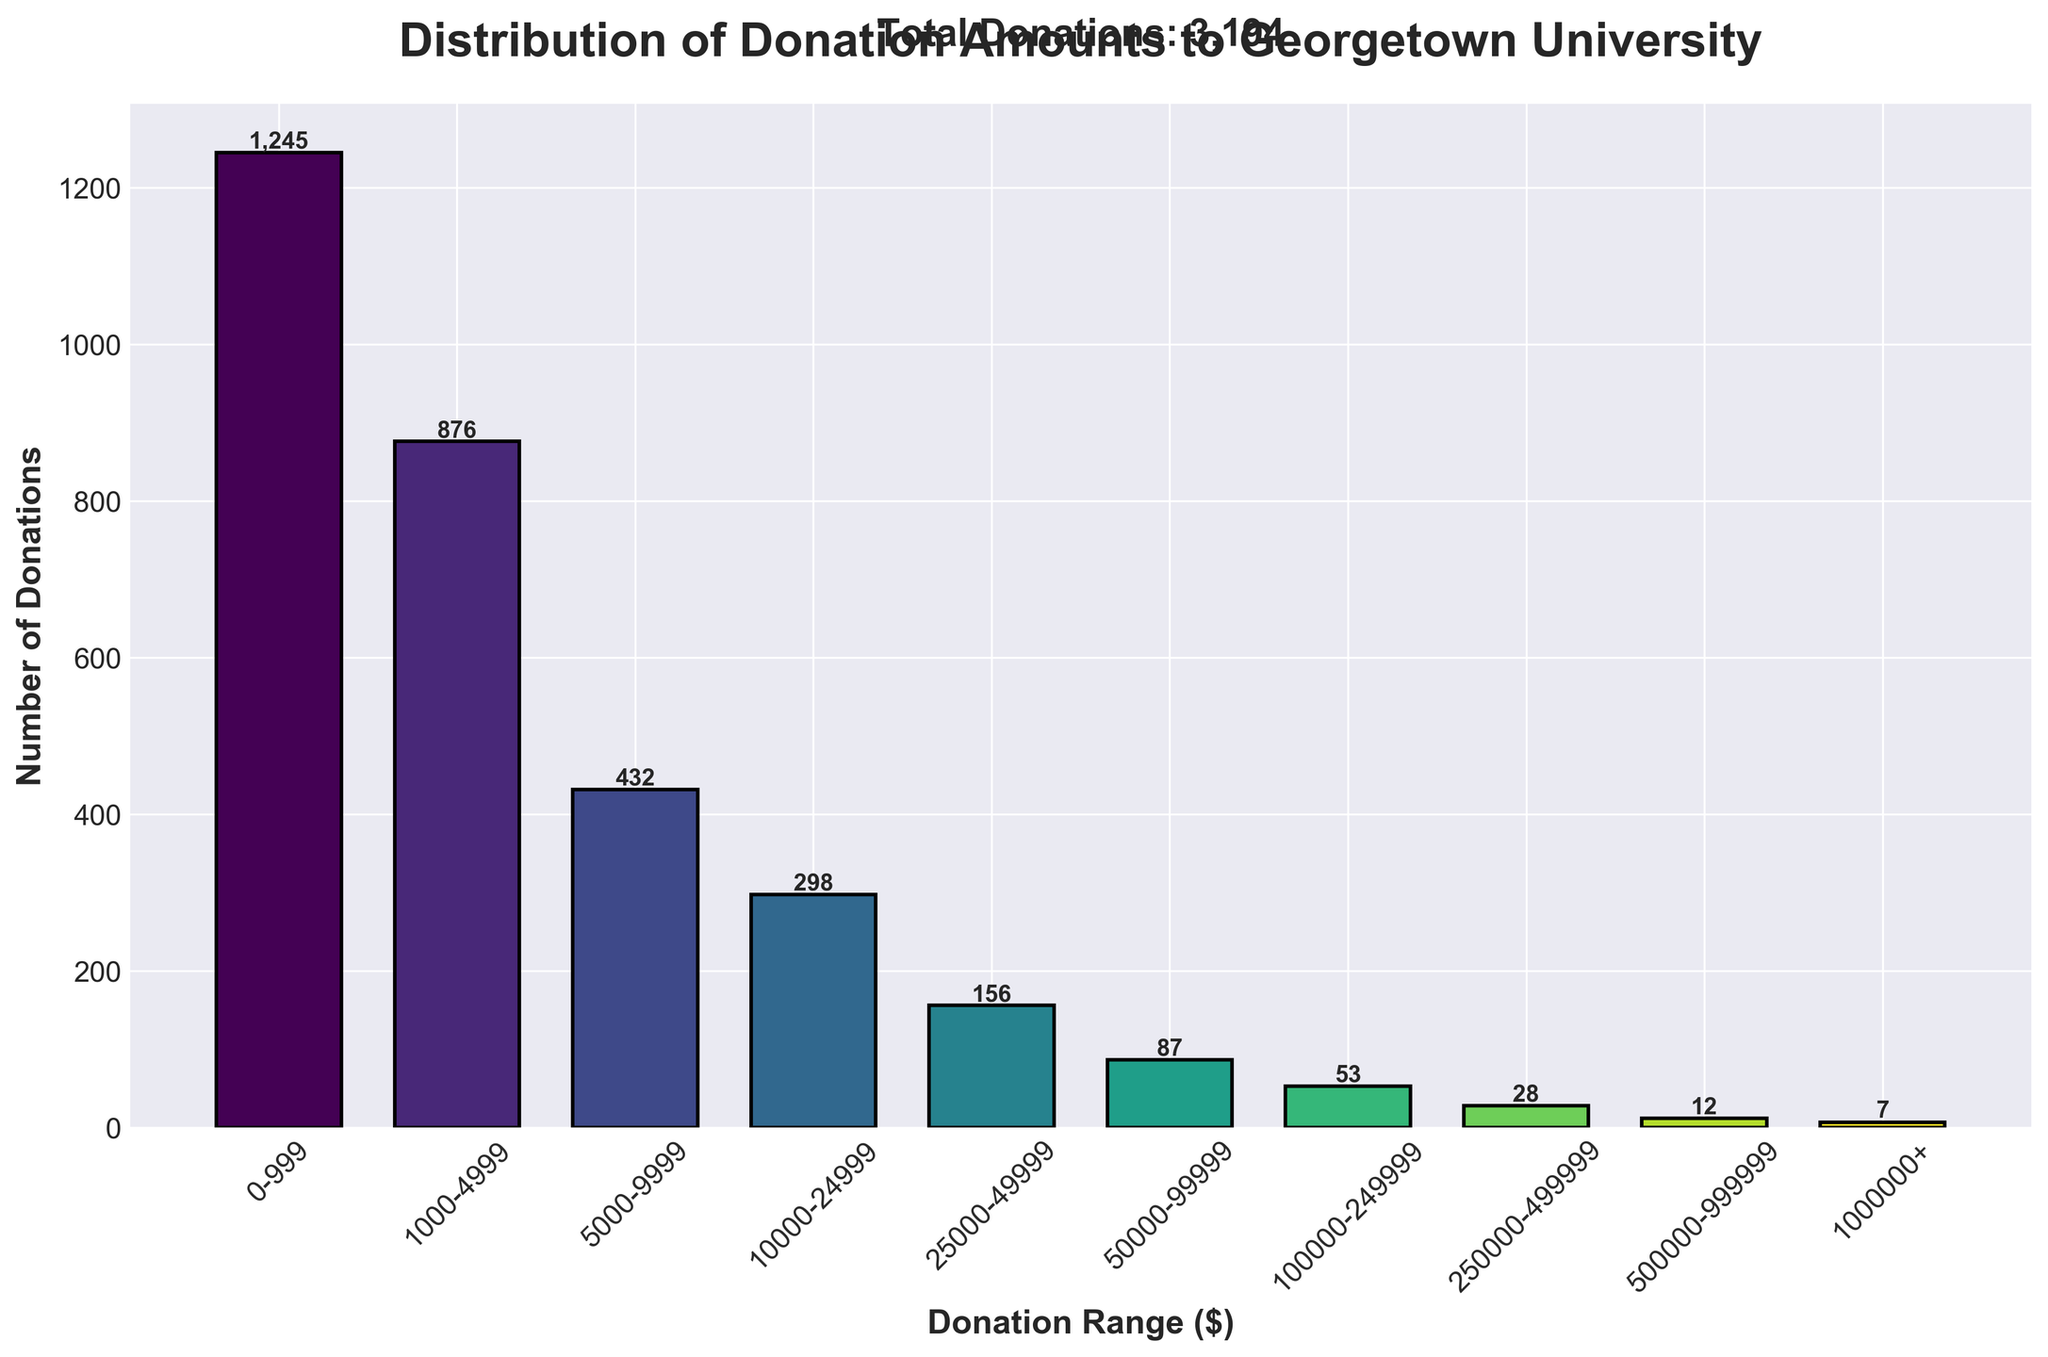What is the title of the histogram? The title of the histogram is shown at the top of the figure. It reads "Distribution of Donation Amounts to Georgetown University".
Answer: Distribution of Donation Amounts to Georgetown University How many donations were in the $10,000-$24,999 range? The number of donations for each range is labeled directly above the bars. For the $10,000-$24,999 range, it reads 298.
Answer: 298 Which donation range has the highest number of donations? Looking at the heights of the bars, the one representing the $0-$999 range is the tallest. Also, the actual number (1245) labeled above this bar is the highest.
Answer: $0-$999 What is the total number of donations made? The total number of donations is mentioned in the text above the histogram, which reports "Total Donations: 3,194".
Answer: 3,194 What is the range with the fewest donations? The shortest bar in the histogram represents the donation range $1,000,000+, and there are 7 donations in this range, which is the smallest number on the chart.
Answer: $1,000,000+ How many donations were above $250,000? To find this, add the number of donations in the $250,000-$499,999, $500,000-$999,999, and $1,000,000+ ranges: 28 + 12 + 7 = 47.
Answer: 47 Compare the number of donations in the $1,000-$4,999 range to those in the $5,000-$9,999 range. Which is higher and by how much? The $1,000-$4,999 range has 876 donations, while the $5,000-$9,999 range has 432. 876 - 432 = 444, so the $1,000-$4,999 range has 444 more donations.
Answer: $1,000-$4,999 by 444 What percentage of the total donations were in the $100,000-$249,999 range? The $100,000-$249,999 range has 53 donations. To find the percentage: (53 / 3,194) * 100 ≈ 1.66%.
Answer: 1.66% Is the number of donations in the $50,000-$99,999 range less than those in the $10,000-$24,999 range? The bar heights and their labels show that $50,000-$99,999 has 87 donations, and $10,000-$24,999 has 298. Therefore, 87 is less than 298.
Answer: Yes Is the sum of donations in the $5,000-$9,999 and $10,000-$24,999 ranges greater than the sum in the $1,000-$4,999 and $25,000-$49,999 ranges? Sum donations in the $5,000-$9,999 and $10,000-$24,999 ranges: 432 + 298 = 730. Sum donations in $1,000-$4,999 and $25,000-$49,999 ranges: 876 + 156 = 1,032. Since 730 is not greater than 1,032, the answer is no.
Answer: No 